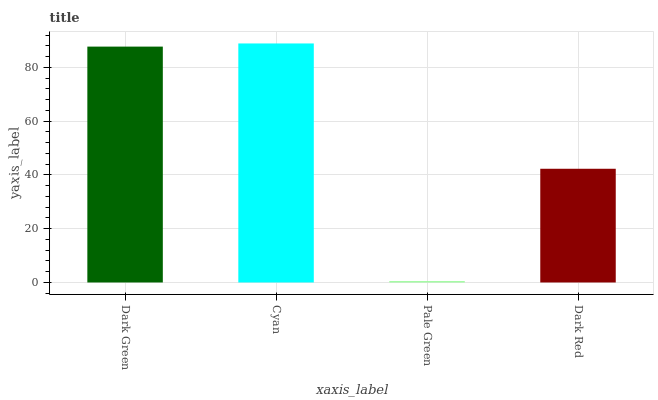Is Pale Green the minimum?
Answer yes or no. Yes. Is Cyan the maximum?
Answer yes or no. Yes. Is Cyan the minimum?
Answer yes or no. No. Is Pale Green the maximum?
Answer yes or no. No. Is Cyan greater than Pale Green?
Answer yes or no. Yes. Is Pale Green less than Cyan?
Answer yes or no. Yes. Is Pale Green greater than Cyan?
Answer yes or no. No. Is Cyan less than Pale Green?
Answer yes or no. No. Is Dark Green the high median?
Answer yes or no. Yes. Is Dark Red the low median?
Answer yes or no. Yes. Is Cyan the high median?
Answer yes or no. No. Is Dark Green the low median?
Answer yes or no. No. 